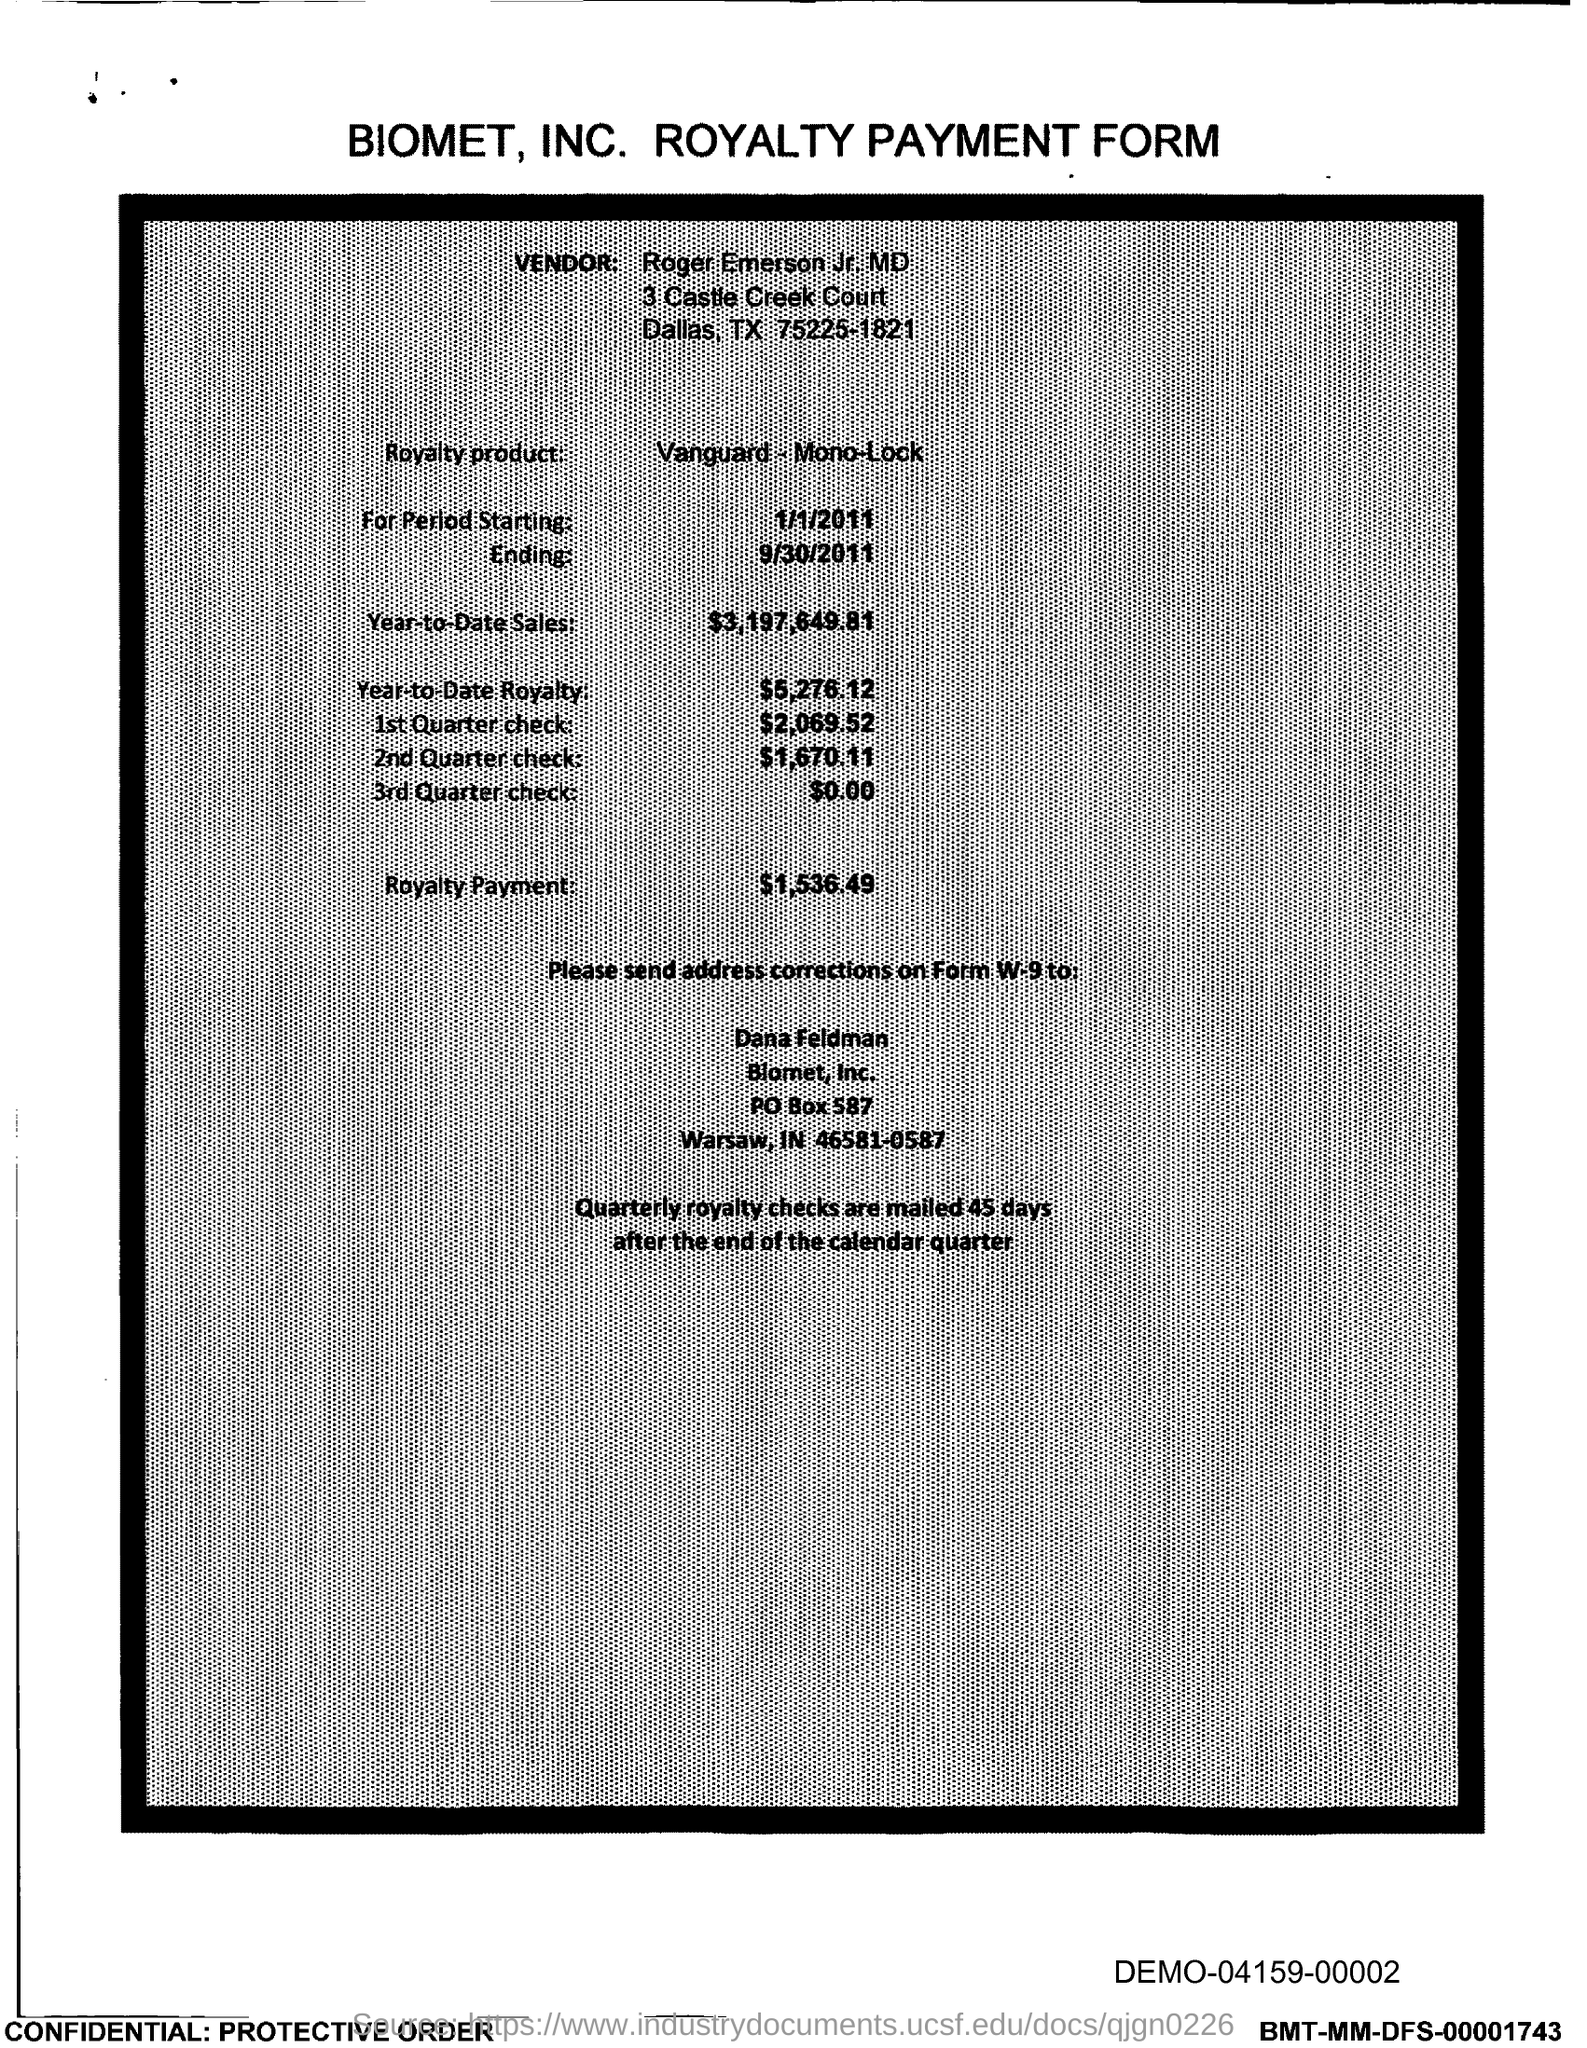What is the PO Box Number mentioned in the document?
Provide a short and direct response. 587. 